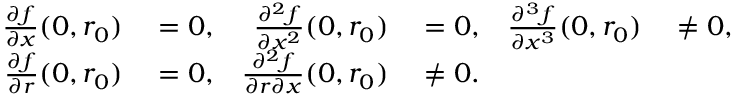<formula> <loc_0><loc_0><loc_500><loc_500>\begin{array} { r l r l r l } { { \frac { \partial f } { \partial x } } ( 0 , r _ { 0 } ) } & = 0 , } & { { \frac { \partial ^ { 2 } f } { \partial x ^ { 2 } } } ( 0 , r _ { 0 } ) } & = 0 , } & { { \frac { \partial ^ { 3 } f } { \partial x ^ { 3 } } } ( 0 , r _ { 0 } ) } & \neq 0 , } \\ { { \frac { \partial f } { \partial r } } ( 0 , r _ { 0 } ) } & = 0 , } & { { \frac { \partial ^ { 2 } f } { \partial r \partial x } } ( 0 , r _ { 0 } ) } & \neq 0 . } \end{array}</formula> 